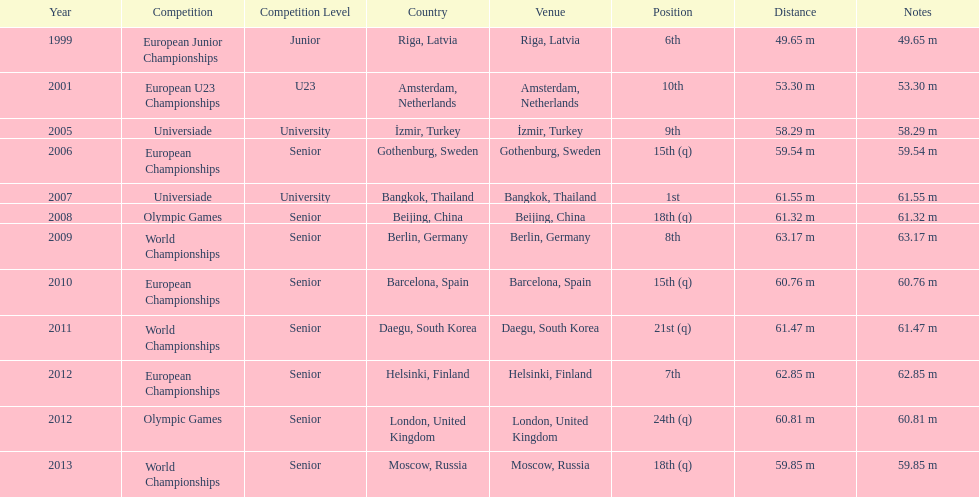Name two events in which mayer competed before he won the bangkok universiade. European Championships, Universiade. 